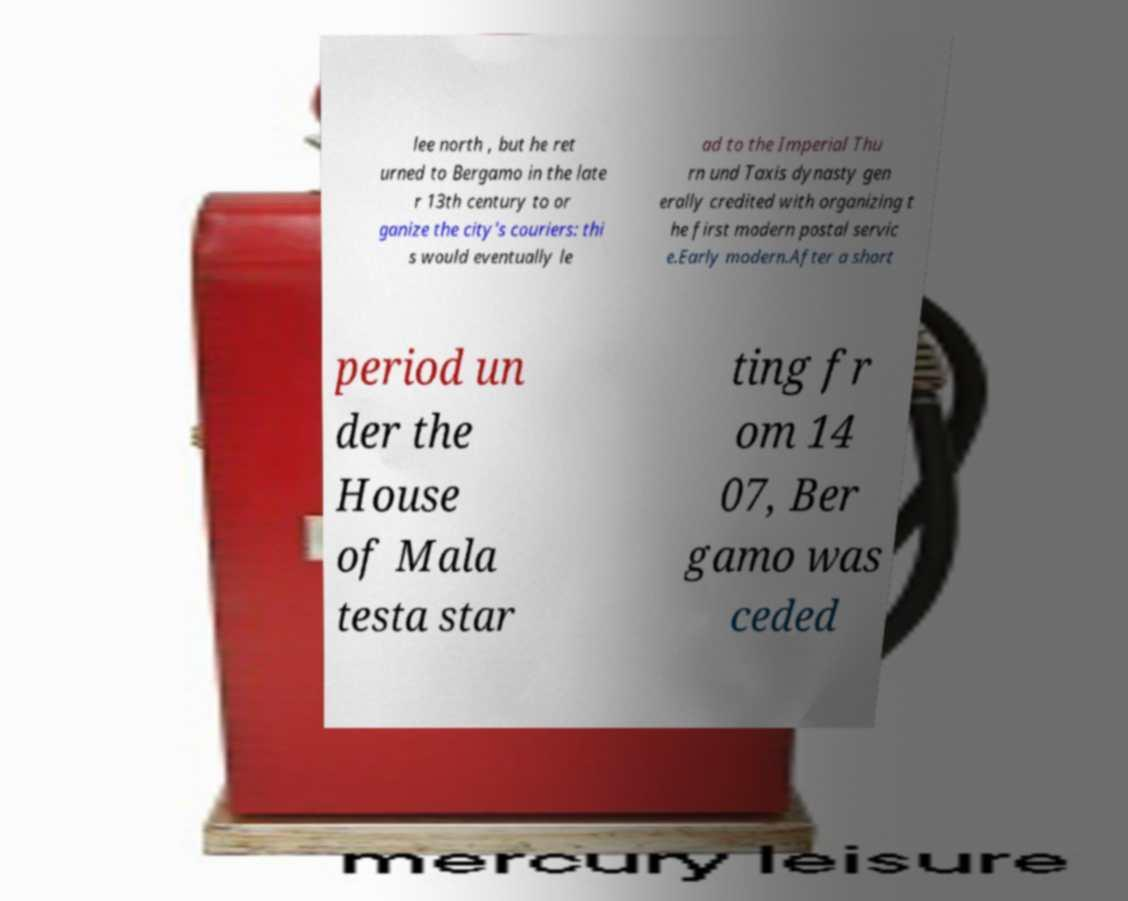There's text embedded in this image that I need extracted. Can you transcribe it verbatim? lee north , but he ret urned to Bergamo in the late r 13th century to or ganize the city's couriers: thi s would eventually le ad to the Imperial Thu rn und Taxis dynasty gen erally credited with organizing t he first modern postal servic e.Early modern.After a short period un der the House of Mala testa star ting fr om 14 07, Ber gamo was ceded 